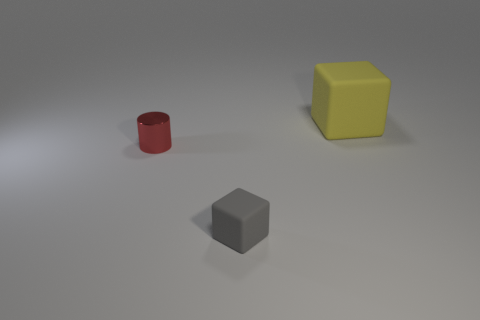How many other things are the same size as the yellow block?
Keep it short and to the point. 0. What is the shape of the matte object in front of the object that is right of the gray cube left of the large yellow object?
Your answer should be very brief. Cube. Do the yellow cube and the rubber thing that is in front of the big yellow matte thing have the same size?
Make the answer very short. No. What color is the thing that is behind the gray matte cube and on the right side of the tiny red shiny cylinder?
Keep it short and to the point. Yellow. What number of other objects are the same shape as the large object?
Make the answer very short. 1. Does the cube in front of the red shiny object have the same color as the cube that is behind the cylinder?
Give a very brief answer. No. There is a matte cube that is left of the large yellow cube; is it the same size as the object that is right of the gray object?
Provide a short and direct response. No. Are there any other things that have the same material as the tiny block?
Your response must be concise. Yes. The gray thing to the left of the matte object right of the rubber object in front of the large yellow cube is made of what material?
Offer a terse response. Rubber. Is the shape of the big matte object the same as the gray rubber thing?
Your response must be concise. Yes. 